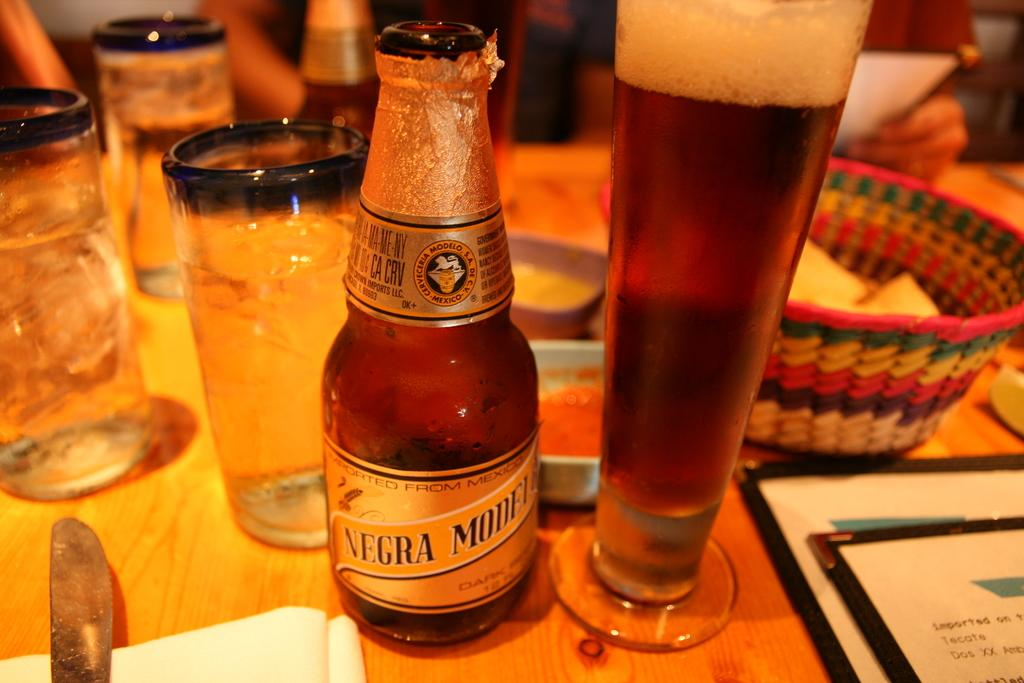<image>
Create a compact narrative representing the image presented. a bottle of negra modelo standing on a table next to a glass full of it 